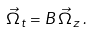<formula> <loc_0><loc_0><loc_500><loc_500>\vec { \Omega } _ { t } = B \, \vec { \Omega } _ { z } \, .</formula> 